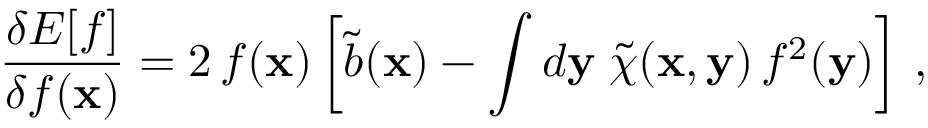Convert formula to latex. <formula><loc_0><loc_0><loc_500><loc_500>\frac { \delta E [ f ] } { \delta f ( { x } ) } = 2 \, f ( { x } ) \left [ \tilde { b } ( { x } ) - \int d { y } \, \tilde { \chi } ( { x } , { y } ) \, f ^ { 2 } ( { y } ) \right ] \, ,</formula> 